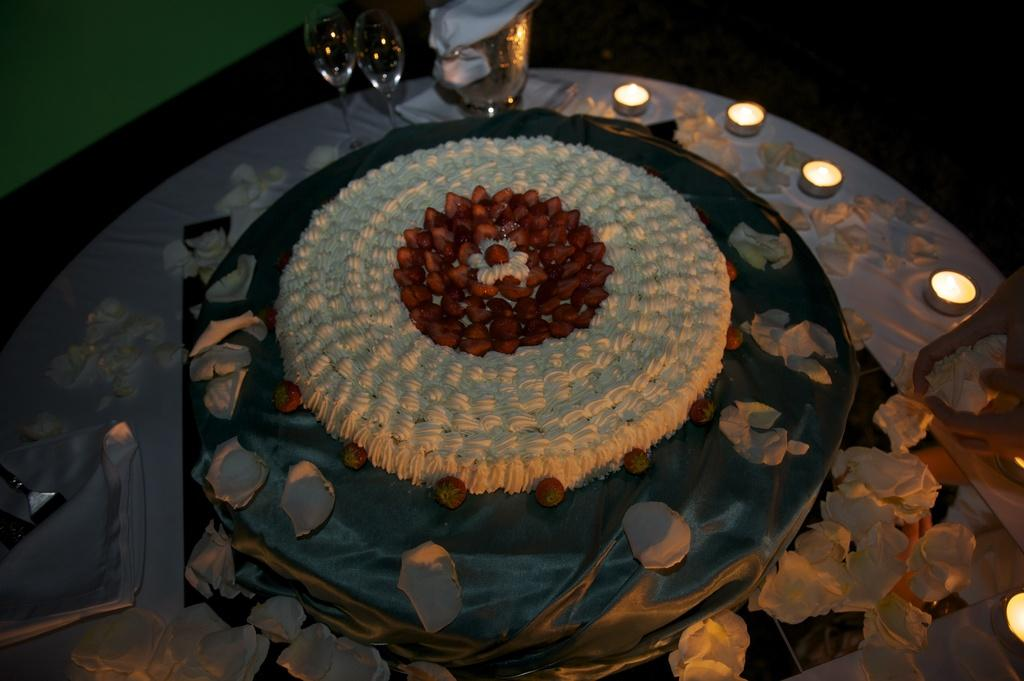What piece of furniture is present in the image? There is a table in the image. What objects are placed on the table? There are glasses and candles on the table. Are there any other items on the table besides glasses and candles? Yes, there are other unspecified things on the table. What type of profit is the committee discussing in the image? There is no committee or discussion of profit in the image; it only shows a table with glasses, candles, and other unspecified items. 